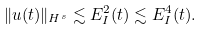<formula> <loc_0><loc_0><loc_500><loc_500>\| u ( t ) \| _ { H ^ { s } } \lesssim E ^ { 2 } _ { I } ( t ) \lesssim E ^ { 4 } _ { I } ( t ) .</formula> 